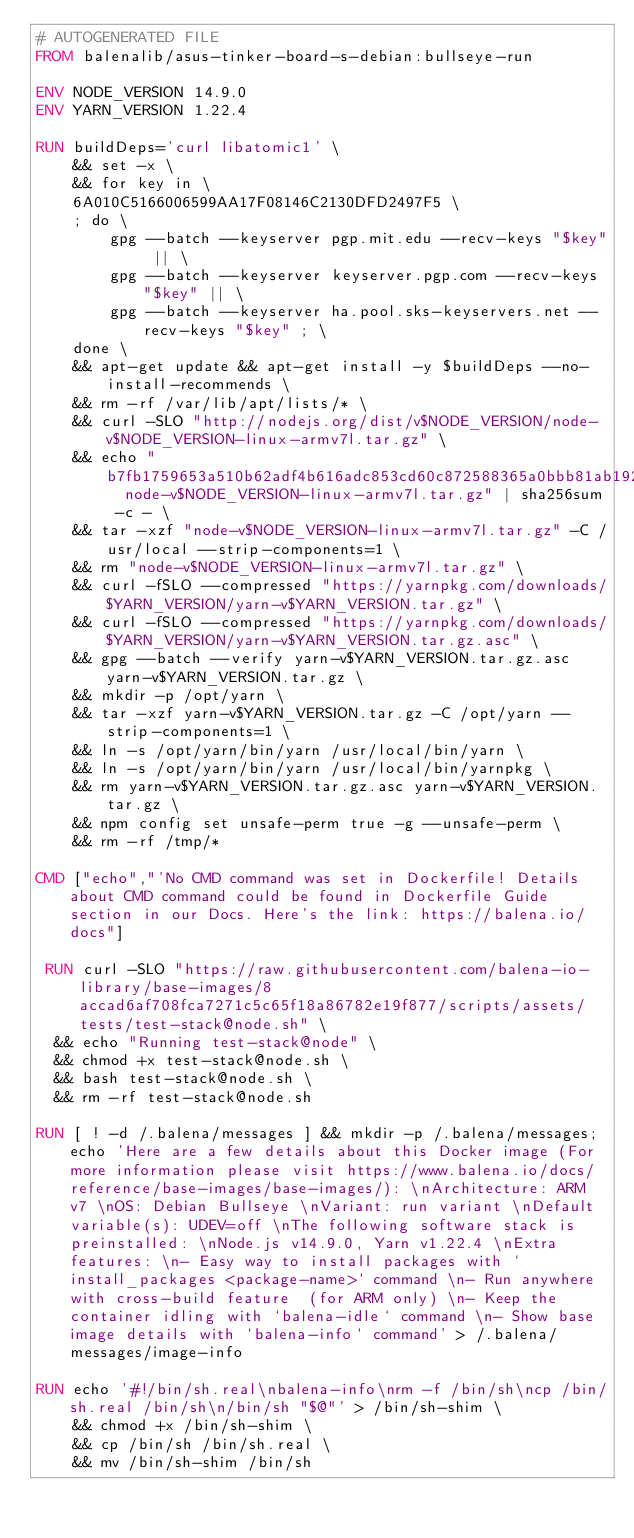<code> <loc_0><loc_0><loc_500><loc_500><_Dockerfile_># AUTOGENERATED FILE
FROM balenalib/asus-tinker-board-s-debian:bullseye-run

ENV NODE_VERSION 14.9.0
ENV YARN_VERSION 1.22.4

RUN buildDeps='curl libatomic1' \
	&& set -x \
	&& for key in \
	6A010C5166006599AA17F08146C2130DFD2497F5 \
	; do \
		gpg --batch --keyserver pgp.mit.edu --recv-keys "$key" || \
		gpg --batch --keyserver keyserver.pgp.com --recv-keys "$key" || \
		gpg --batch --keyserver ha.pool.sks-keyservers.net --recv-keys "$key" ; \
	done \
	&& apt-get update && apt-get install -y $buildDeps --no-install-recommends \
	&& rm -rf /var/lib/apt/lists/* \
	&& curl -SLO "http://nodejs.org/dist/v$NODE_VERSION/node-v$NODE_VERSION-linux-armv7l.tar.gz" \
	&& echo "b7fb1759653a510b62adf4b616adc853cd60c872588365a0bbb81ab192bc06ba  node-v$NODE_VERSION-linux-armv7l.tar.gz" | sha256sum -c - \
	&& tar -xzf "node-v$NODE_VERSION-linux-armv7l.tar.gz" -C /usr/local --strip-components=1 \
	&& rm "node-v$NODE_VERSION-linux-armv7l.tar.gz" \
	&& curl -fSLO --compressed "https://yarnpkg.com/downloads/$YARN_VERSION/yarn-v$YARN_VERSION.tar.gz" \
	&& curl -fSLO --compressed "https://yarnpkg.com/downloads/$YARN_VERSION/yarn-v$YARN_VERSION.tar.gz.asc" \
	&& gpg --batch --verify yarn-v$YARN_VERSION.tar.gz.asc yarn-v$YARN_VERSION.tar.gz \
	&& mkdir -p /opt/yarn \
	&& tar -xzf yarn-v$YARN_VERSION.tar.gz -C /opt/yarn --strip-components=1 \
	&& ln -s /opt/yarn/bin/yarn /usr/local/bin/yarn \
	&& ln -s /opt/yarn/bin/yarn /usr/local/bin/yarnpkg \
	&& rm yarn-v$YARN_VERSION.tar.gz.asc yarn-v$YARN_VERSION.tar.gz \
	&& npm config set unsafe-perm true -g --unsafe-perm \
	&& rm -rf /tmp/*

CMD ["echo","'No CMD command was set in Dockerfile! Details about CMD command could be found in Dockerfile Guide section in our Docs. Here's the link: https://balena.io/docs"]

 RUN curl -SLO "https://raw.githubusercontent.com/balena-io-library/base-images/8accad6af708fca7271c5c65f18a86782e19f877/scripts/assets/tests/test-stack@node.sh" \
  && echo "Running test-stack@node" \
  && chmod +x test-stack@node.sh \
  && bash test-stack@node.sh \
  && rm -rf test-stack@node.sh 

RUN [ ! -d /.balena/messages ] && mkdir -p /.balena/messages; echo 'Here are a few details about this Docker image (For more information please visit https://www.balena.io/docs/reference/base-images/base-images/): \nArchitecture: ARM v7 \nOS: Debian Bullseye \nVariant: run variant \nDefault variable(s): UDEV=off \nThe following software stack is preinstalled: \nNode.js v14.9.0, Yarn v1.22.4 \nExtra features: \n- Easy way to install packages with `install_packages <package-name>` command \n- Run anywhere with cross-build feature  (for ARM only) \n- Keep the container idling with `balena-idle` command \n- Show base image details with `balena-info` command' > /.balena/messages/image-info

RUN echo '#!/bin/sh.real\nbalena-info\nrm -f /bin/sh\ncp /bin/sh.real /bin/sh\n/bin/sh "$@"' > /bin/sh-shim \
	&& chmod +x /bin/sh-shim \
	&& cp /bin/sh /bin/sh.real \
	&& mv /bin/sh-shim /bin/sh</code> 